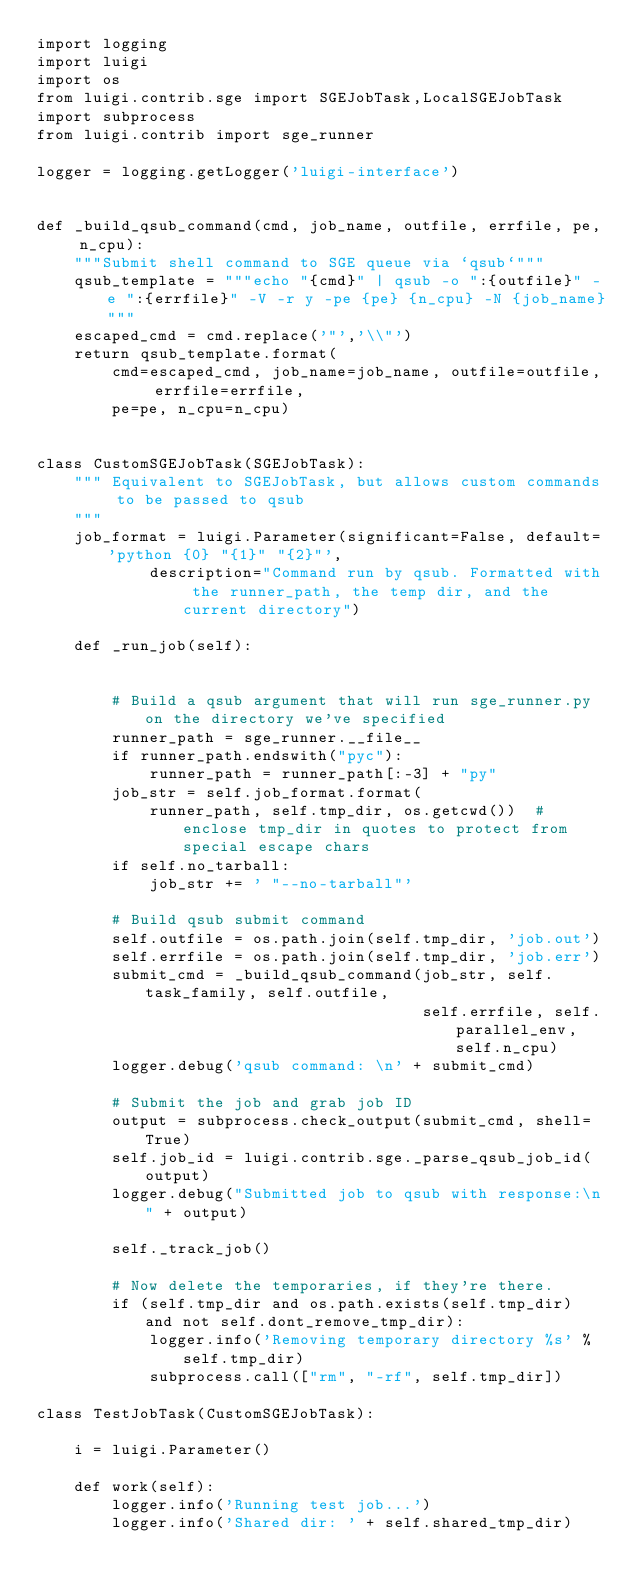<code> <loc_0><loc_0><loc_500><loc_500><_Python_>import logging
import luigi
import os
from luigi.contrib.sge import SGEJobTask,LocalSGEJobTask
import subprocess
from luigi.contrib import sge_runner

logger = logging.getLogger('luigi-interface')


def _build_qsub_command(cmd, job_name, outfile, errfile, pe, n_cpu):
    """Submit shell command to SGE queue via `qsub`"""
    qsub_template = """echo "{cmd}" | qsub -o ":{outfile}" -e ":{errfile}" -V -r y -pe {pe} {n_cpu} -N {job_name}"""
    escaped_cmd = cmd.replace('"','\\"')
    return qsub_template.format(
        cmd=escaped_cmd, job_name=job_name, outfile=outfile, errfile=errfile,
        pe=pe, n_cpu=n_cpu)


class CustomSGEJobTask(SGEJobTask):
    """ Equivalent to SGEJobTask, but allows custom commands to be passed to qsub
    """
    job_format = luigi.Parameter(significant=False, default='python {0} "{1}" "{2}"',
            description="Command run by qsub. Formatted with the runner_path, the temp dir, and the current directory")

    def _run_job(self):
 

        # Build a qsub argument that will run sge_runner.py on the directory we've specified
        runner_path = sge_runner.__file__
        if runner_path.endswith("pyc"):
            runner_path = runner_path[:-3] + "py"
        job_str = self.job_format.format(
            runner_path, self.tmp_dir, os.getcwd())  # enclose tmp_dir in quotes to protect from special escape chars
        if self.no_tarball:
            job_str += ' "--no-tarball"'

        # Build qsub submit command
        self.outfile = os.path.join(self.tmp_dir, 'job.out')
        self.errfile = os.path.join(self.tmp_dir, 'job.err')
        submit_cmd = _build_qsub_command(job_str, self.task_family, self.outfile,
                                         self.errfile, self.parallel_env, self.n_cpu)
        logger.debug('qsub command: \n' + submit_cmd)

        # Submit the job and grab job ID
        output = subprocess.check_output(submit_cmd, shell=True)
        self.job_id = luigi.contrib.sge._parse_qsub_job_id(output)
        logger.debug("Submitted job to qsub with response:\n" + output)

        self._track_job()

        # Now delete the temporaries, if they're there.
        if (self.tmp_dir and os.path.exists(self.tmp_dir) and not self.dont_remove_tmp_dir):
            logger.info('Removing temporary directory %s' % self.tmp_dir)
            subprocess.call(["rm", "-rf", self.tmp_dir])

class TestJobTask(CustomSGEJobTask):

    i = luigi.Parameter()

    def work(self):
        logger.info('Running test job...')
        logger.info('Shared dir: ' + self.shared_tmp_dir)</code> 